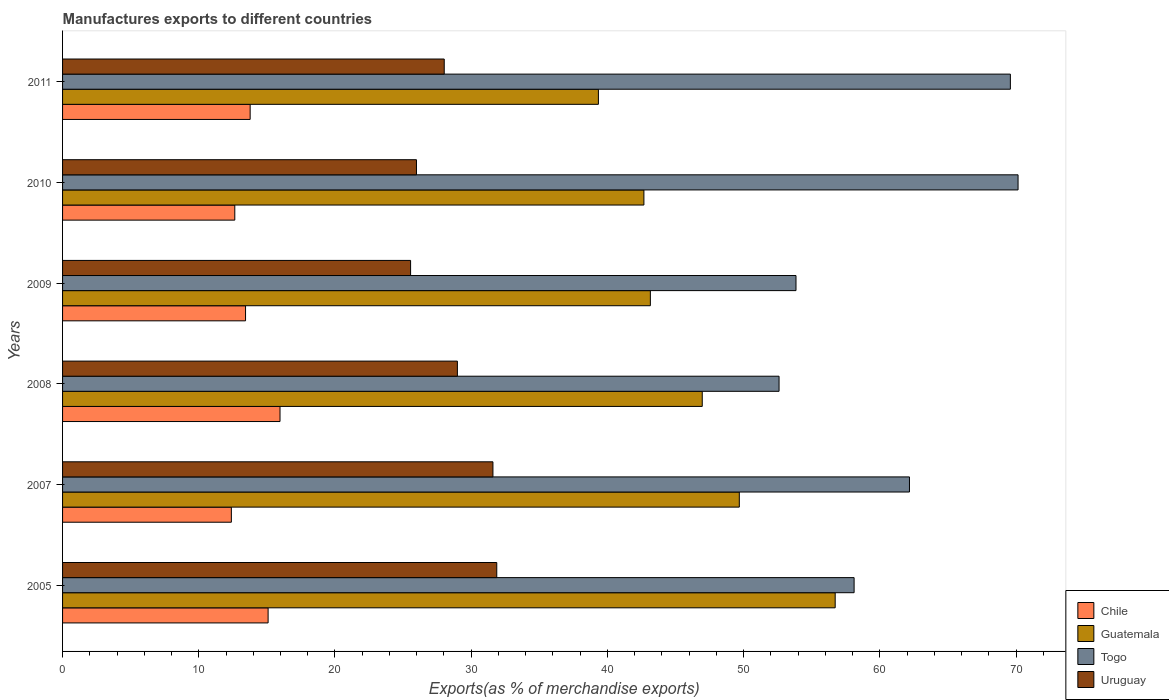How many groups of bars are there?
Ensure brevity in your answer.  6. How many bars are there on the 1st tick from the bottom?
Give a very brief answer. 4. In how many cases, is the number of bars for a given year not equal to the number of legend labels?
Offer a terse response. 0. What is the percentage of exports to different countries in Togo in 2007?
Give a very brief answer. 62.18. Across all years, what is the maximum percentage of exports to different countries in Togo?
Provide a succinct answer. 70.15. Across all years, what is the minimum percentage of exports to different countries in Chile?
Offer a very short reply. 12.39. What is the total percentage of exports to different countries in Uruguay in the graph?
Offer a very short reply. 172.01. What is the difference between the percentage of exports to different countries in Chile in 2005 and that in 2010?
Your response must be concise. 2.45. What is the difference between the percentage of exports to different countries in Uruguay in 2005 and the percentage of exports to different countries in Chile in 2007?
Make the answer very short. 19.49. What is the average percentage of exports to different countries in Chile per year?
Make the answer very short. 13.88. In the year 2008, what is the difference between the percentage of exports to different countries in Togo and percentage of exports to different countries in Chile?
Offer a very short reply. 36.64. What is the ratio of the percentage of exports to different countries in Togo in 2007 to that in 2011?
Your answer should be very brief. 0.89. Is the percentage of exports to different countries in Togo in 2007 less than that in 2011?
Your response must be concise. Yes. What is the difference between the highest and the second highest percentage of exports to different countries in Uruguay?
Your answer should be compact. 0.28. What is the difference between the highest and the lowest percentage of exports to different countries in Uruguay?
Offer a very short reply. 6.33. Is the sum of the percentage of exports to different countries in Uruguay in 2005 and 2007 greater than the maximum percentage of exports to different countries in Chile across all years?
Your answer should be compact. Yes. Is it the case that in every year, the sum of the percentage of exports to different countries in Togo and percentage of exports to different countries in Uruguay is greater than the sum of percentage of exports to different countries in Chile and percentage of exports to different countries in Guatemala?
Offer a very short reply. Yes. What does the 1st bar from the top in 2010 represents?
Provide a short and direct response. Uruguay. What does the 2nd bar from the bottom in 2008 represents?
Provide a succinct answer. Guatemala. Is it the case that in every year, the sum of the percentage of exports to different countries in Togo and percentage of exports to different countries in Guatemala is greater than the percentage of exports to different countries in Chile?
Offer a terse response. Yes. How many bars are there?
Your response must be concise. 24. How many years are there in the graph?
Ensure brevity in your answer.  6. Does the graph contain grids?
Your response must be concise. No. Where does the legend appear in the graph?
Provide a short and direct response. Bottom right. What is the title of the graph?
Your answer should be very brief. Manufactures exports to different countries. What is the label or title of the X-axis?
Provide a succinct answer. Exports(as % of merchandise exports). What is the Exports(as % of merchandise exports) in Chile in 2005?
Offer a terse response. 15.09. What is the Exports(as % of merchandise exports) in Guatemala in 2005?
Provide a succinct answer. 56.72. What is the Exports(as % of merchandise exports) of Togo in 2005?
Offer a terse response. 58.11. What is the Exports(as % of merchandise exports) in Uruguay in 2005?
Give a very brief answer. 31.88. What is the Exports(as % of merchandise exports) in Chile in 2007?
Ensure brevity in your answer.  12.39. What is the Exports(as % of merchandise exports) in Guatemala in 2007?
Your answer should be very brief. 49.68. What is the Exports(as % of merchandise exports) in Togo in 2007?
Provide a succinct answer. 62.18. What is the Exports(as % of merchandise exports) in Uruguay in 2007?
Give a very brief answer. 31.6. What is the Exports(as % of merchandise exports) of Chile in 2008?
Your response must be concise. 15.96. What is the Exports(as % of merchandise exports) of Guatemala in 2008?
Your answer should be compact. 46.96. What is the Exports(as % of merchandise exports) in Togo in 2008?
Offer a very short reply. 52.6. What is the Exports(as % of merchandise exports) in Uruguay in 2008?
Ensure brevity in your answer.  28.99. What is the Exports(as % of merchandise exports) in Chile in 2009?
Your answer should be compact. 13.43. What is the Exports(as % of merchandise exports) in Guatemala in 2009?
Your answer should be compact. 43.15. What is the Exports(as % of merchandise exports) of Togo in 2009?
Make the answer very short. 53.85. What is the Exports(as % of merchandise exports) in Uruguay in 2009?
Offer a terse response. 25.55. What is the Exports(as % of merchandise exports) of Chile in 2010?
Offer a very short reply. 12.64. What is the Exports(as % of merchandise exports) of Guatemala in 2010?
Your answer should be compact. 42.68. What is the Exports(as % of merchandise exports) of Togo in 2010?
Offer a very short reply. 70.15. What is the Exports(as % of merchandise exports) of Uruguay in 2010?
Provide a succinct answer. 25.98. What is the Exports(as % of merchandise exports) of Chile in 2011?
Make the answer very short. 13.77. What is the Exports(as % of merchandise exports) of Guatemala in 2011?
Your response must be concise. 39.34. What is the Exports(as % of merchandise exports) of Togo in 2011?
Offer a very short reply. 69.58. What is the Exports(as % of merchandise exports) in Uruguay in 2011?
Your response must be concise. 28.02. Across all years, what is the maximum Exports(as % of merchandise exports) in Chile?
Your answer should be very brief. 15.96. Across all years, what is the maximum Exports(as % of merchandise exports) in Guatemala?
Provide a short and direct response. 56.72. Across all years, what is the maximum Exports(as % of merchandise exports) in Togo?
Your response must be concise. 70.15. Across all years, what is the maximum Exports(as % of merchandise exports) in Uruguay?
Ensure brevity in your answer.  31.88. Across all years, what is the minimum Exports(as % of merchandise exports) in Chile?
Your answer should be compact. 12.39. Across all years, what is the minimum Exports(as % of merchandise exports) of Guatemala?
Ensure brevity in your answer.  39.34. Across all years, what is the minimum Exports(as % of merchandise exports) of Togo?
Keep it short and to the point. 52.6. Across all years, what is the minimum Exports(as % of merchandise exports) in Uruguay?
Your answer should be compact. 25.55. What is the total Exports(as % of merchandise exports) of Chile in the graph?
Provide a short and direct response. 83.3. What is the total Exports(as % of merchandise exports) of Guatemala in the graph?
Provide a short and direct response. 278.54. What is the total Exports(as % of merchandise exports) in Togo in the graph?
Your response must be concise. 366.47. What is the total Exports(as % of merchandise exports) of Uruguay in the graph?
Give a very brief answer. 172.01. What is the difference between the Exports(as % of merchandise exports) of Chile in 2005 and that in 2007?
Keep it short and to the point. 2.7. What is the difference between the Exports(as % of merchandise exports) in Guatemala in 2005 and that in 2007?
Provide a succinct answer. 7.04. What is the difference between the Exports(as % of merchandise exports) in Togo in 2005 and that in 2007?
Your response must be concise. -4.06. What is the difference between the Exports(as % of merchandise exports) of Uruguay in 2005 and that in 2007?
Make the answer very short. 0.28. What is the difference between the Exports(as % of merchandise exports) in Chile in 2005 and that in 2008?
Your answer should be compact. -0.87. What is the difference between the Exports(as % of merchandise exports) of Guatemala in 2005 and that in 2008?
Your answer should be compact. 9.76. What is the difference between the Exports(as % of merchandise exports) in Togo in 2005 and that in 2008?
Your answer should be compact. 5.51. What is the difference between the Exports(as % of merchandise exports) in Uruguay in 2005 and that in 2008?
Provide a short and direct response. 2.89. What is the difference between the Exports(as % of merchandise exports) in Chile in 2005 and that in 2009?
Your answer should be very brief. 1.66. What is the difference between the Exports(as % of merchandise exports) in Guatemala in 2005 and that in 2009?
Your answer should be compact. 13.57. What is the difference between the Exports(as % of merchandise exports) in Togo in 2005 and that in 2009?
Your answer should be very brief. 4.27. What is the difference between the Exports(as % of merchandise exports) in Uruguay in 2005 and that in 2009?
Offer a very short reply. 6.33. What is the difference between the Exports(as % of merchandise exports) of Chile in 2005 and that in 2010?
Your answer should be very brief. 2.45. What is the difference between the Exports(as % of merchandise exports) of Guatemala in 2005 and that in 2010?
Keep it short and to the point. 14.04. What is the difference between the Exports(as % of merchandise exports) of Togo in 2005 and that in 2010?
Make the answer very short. -12.04. What is the difference between the Exports(as % of merchandise exports) of Uruguay in 2005 and that in 2010?
Your response must be concise. 5.9. What is the difference between the Exports(as % of merchandise exports) of Chile in 2005 and that in 2011?
Make the answer very short. 1.32. What is the difference between the Exports(as % of merchandise exports) in Guatemala in 2005 and that in 2011?
Offer a terse response. 17.38. What is the difference between the Exports(as % of merchandise exports) of Togo in 2005 and that in 2011?
Provide a succinct answer. -11.47. What is the difference between the Exports(as % of merchandise exports) of Uruguay in 2005 and that in 2011?
Provide a short and direct response. 3.86. What is the difference between the Exports(as % of merchandise exports) of Chile in 2007 and that in 2008?
Offer a very short reply. -3.57. What is the difference between the Exports(as % of merchandise exports) in Guatemala in 2007 and that in 2008?
Your answer should be very brief. 2.72. What is the difference between the Exports(as % of merchandise exports) in Togo in 2007 and that in 2008?
Provide a succinct answer. 9.57. What is the difference between the Exports(as % of merchandise exports) in Uruguay in 2007 and that in 2008?
Provide a succinct answer. 2.61. What is the difference between the Exports(as % of merchandise exports) of Chile in 2007 and that in 2009?
Offer a very short reply. -1.04. What is the difference between the Exports(as % of merchandise exports) of Guatemala in 2007 and that in 2009?
Make the answer very short. 6.53. What is the difference between the Exports(as % of merchandise exports) of Togo in 2007 and that in 2009?
Provide a succinct answer. 8.33. What is the difference between the Exports(as % of merchandise exports) of Uruguay in 2007 and that in 2009?
Make the answer very short. 6.04. What is the difference between the Exports(as % of merchandise exports) of Chile in 2007 and that in 2010?
Ensure brevity in your answer.  -0.25. What is the difference between the Exports(as % of merchandise exports) in Guatemala in 2007 and that in 2010?
Provide a succinct answer. 7. What is the difference between the Exports(as % of merchandise exports) of Togo in 2007 and that in 2010?
Offer a terse response. -7.97. What is the difference between the Exports(as % of merchandise exports) in Uruguay in 2007 and that in 2010?
Your answer should be very brief. 5.61. What is the difference between the Exports(as % of merchandise exports) in Chile in 2007 and that in 2011?
Keep it short and to the point. -1.38. What is the difference between the Exports(as % of merchandise exports) of Guatemala in 2007 and that in 2011?
Ensure brevity in your answer.  10.34. What is the difference between the Exports(as % of merchandise exports) in Togo in 2007 and that in 2011?
Give a very brief answer. -7.41. What is the difference between the Exports(as % of merchandise exports) of Uruguay in 2007 and that in 2011?
Offer a very short reply. 3.58. What is the difference between the Exports(as % of merchandise exports) of Chile in 2008 and that in 2009?
Offer a very short reply. 2.53. What is the difference between the Exports(as % of merchandise exports) in Guatemala in 2008 and that in 2009?
Your answer should be very brief. 3.81. What is the difference between the Exports(as % of merchandise exports) of Togo in 2008 and that in 2009?
Your response must be concise. -1.24. What is the difference between the Exports(as % of merchandise exports) in Uruguay in 2008 and that in 2009?
Offer a terse response. 3.44. What is the difference between the Exports(as % of merchandise exports) of Chile in 2008 and that in 2010?
Keep it short and to the point. 3.32. What is the difference between the Exports(as % of merchandise exports) of Guatemala in 2008 and that in 2010?
Your response must be concise. 4.28. What is the difference between the Exports(as % of merchandise exports) in Togo in 2008 and that in 2010?
Your answer should be very brief. -17.55. What is the difference between the Exports(as % of merchandise exports) in Uruguay in 2008 and that in 2010?
Offer a very short reply. 3. What is the difference between the Exports(as % of merchandise exports) in Chile in 2008 and that in 2011?
Give a very brief answer. 2.19. What is the difference between the Exports(as % of merchandise exports) in Guatemala in 2008 and that in 2011?
Provide a short and direct response. 7.62. What is the difference between the Exports(as % of merchandise exports) of Togo in 2008 and that in 2011?
Your answer should be very brief. -16.98. What is the difference between the Exports(as % of merchandise exports) in Uruguay in 2008 and that in 2011?
Provide a succinct answer. 0.97. What is the difference between the Exports(as % of merchandise exports) of Chile in 2009 and that in 2010?
Give a very brief answer. 0.79. What is the difference between the Exports(as % of merchandise exports) in Guatemala in 2009 and that in 2010?
Your answer should be very brief. 0.47. What is the difference between the Exports(as % of merchandise exports) in Togo in 2009 and that in 2010?
Offer a very short reply. -16.3. What is the difference between the Exports(as % of merchandise exports) of Uruguay in 2009 and that in 2010?
Your answer should be compact. -0.43. What is the difference between the Exports(as % of merchandise exports) in Chile in 2009 and that in 2011?
Your response must be concise. -0.34. What is the difference between the Exports(as % of merchandise exports) of Guatemala in 2009 and that in 2011?
Offer a very short reply. 3.81. What is the difference between the Exports(as % of merchandise exports) of Togo in 2009 and that in 2011?
Your response must be concise. -15.74. What is the difference between the Exports(as % of merchandise exports) of Uruguay in 2009 and that in 2011?
Provide a succinct answer. -2.47. What is the difference between the Exports(as % of merchandise exports) of Chile in 2010 and that in 2011?
Provide a succinct answer. -1.13. What is the difference between the Exports(as % of merchandise exports) in Guatemala in 2010 and that in 2011?
Make the answer very short. 3.34. What is the difference between the Exports(as % of merchandise exports) of Togo in 2010 and that in 2011?
Give a very brief answer. 0.56. What is the difference between the Exports(as % of merchandise exports) in Uruguay in 2010 and that in 2011?
Your response must be concise. -2.04. What is the difference between the Exports(as % of merchandise exports) in Chile in 2005 and the Exports(as % of merchandise exports) in Guatemala in 2007?
Offer a very short reply. -34.59. What is the difference between the Exports(as % of merchandise exports) in Chile in 2005 and the Exports(as % of merchandise exports) in Togo in 2007?
Your answer should be very brief. -47.09. What is the difference between the Exports(as % of merchandise exports) of Chile in 2005 and the Exports(as % of merchandise exports) of Uruguay in 2007?
Your response must be concise. -16.51. What is the difference between the Exports(as % of merchandise exports) in Guatemala in 2005 and the Exports(as % of merchandise exports) in Togo in 2007?
Keep it short and to the point. -5.45. What is the difference between the Exports(as % of merchandise exports) in Guatemala in 2005 and the Exports(as % of merchandise exports) in Uruguay in 2007?
Provide a succinct answer. 25.13. What is the difference between the Exports(as % of merchandise exports) of Togo in 2005 and the Exports(as % of merchandise exports) of Uruguay in 2007?
Keep it short and to the point. 26.52. What is the difference between the Exports(as % of merchandise exports) of Chile in 2005 and the Exports(as % of merchandise exports) of Guatemala in 2008?
Your response must be concise. -31.87. What is the difference between the Exports(as % of merchandise exports) of Chile in 2005 and the Exports(as % of merchandise exports) of Togo in 2008?
Your answer should be very brief. -37.51. What is the difference between the Exports(as % of merchandise exports) of Chile in 2005 and the Exports(as % of merchandise exports) of Uruguay in 2008?
Your response must be concise. -13.9. What is the difference between the Exports(as % of merchandise exports) in Guatemala in 2005 and the Exports(as % of merchandise exports) in Togo in 2008?
Offer a very short reply. 4.12. What is the difference between the Exports(as % of merchandise exports) of Guatemala in 2005 and the Exports(as % of merchandise exports) of Uruguay in 2008?
Your answer should be compact. 27.74. What is the difference between the Exports(as % of merchandise exports) of Togo in 2005 and the Exports(as % of merchandise exports) of Uruguay in 2008?
Your response must be concise. 29.12. What is the difference between the Exports(as % of merchandise exports) of Chile in 2005 and the Exports(as % of merchandise exports) of Guatemala in 2009?
Give a very brief answer. -28.06. What is the difference between the Exports(as % of merchandise exports) in Chile in 2005 and the Exports(as % of merchandise exports) in Togo in 2009?
Your answer should be compact. -38.76. What is the difference between the Exports(as % of merchandise exports) of Chile in 2005 and the Exports(as % of merchandise exports) of Uruguay in 2009?
Provide a short and direct response. -10.46. What is the difference between the Exports(as % of merchandise exports) of Guatemala in 2005 and the Exports(as % of merchandise exports) of Togo in 2009?
Your response must be concise. 2.88. What is the difference between the Exports(as % of merchandise exports) of Guatemala in 2005 and the Exports(as % of merchandise exports) of Uruguay in 2009?
Your response must be concise. 31.17. What is the difference between the Exports(as % of merchandise exports) in Togo in 2005 and the Exports(as % of merchandise exports) in Uruguay in 2009?
Ensure brevity in your answer.  32.56. What is the difference between the Exports(as % of merchandise exports) in Chile in 2005 and the Exports(as % of merchandise exports) in Guatemala in 2010?
Offer a very short reply. -27.59. What is the difference between the Exports(as % of merchandise exports) of Chile in 2005 and the Exports(as % of merchandise exports) of Togo in 2010?
Keep it short and to the point. -55.06. What is the difference between the Exports(as % of merchandise exports) of Chile in 2005 and the Exports(as % of merchandise exports) of Uruguay in 2010?
Your response must be concise. -10.89. What is the difference between the Exports(as % of merchandise exports) of Guatemala in 2005 and the Exports(as % of merchandise exports) of Togo in 2010?
Offer a terse response. -13.43. What is the difference between the Exports(as % of merchandise exports) of Guatemala in 2005 and the Exports(as % of merchandise exports) of Uruguay in 2010?
Your response must be concise. 30.74. What is the difference between the Exports(as % of merchandise exports) of Togo in 2005 and the Exports(as % of merchandise exports) of Uruguay in 2010?
Offer a very short reply. 32.13. What is the difference between the Exports(as % of merchandise exports) of Chile in 2005 and the Exports(as % of merchandise exports) of Guatemala in 2011?
Your answer should be very brief. -24.25. What is the difference between the Exports(as % of merchandise exports) of Chile in 2005 and the Exports(as % of merchandise exports) of Togo in 2011?
Ensure brevity in your answer.  -54.49. What is the difference between the Exports(as % of merchandise exports) of Chile in 2005 and the Exports(as % of merchandise exports) of Uruguay in 2011?
Give a very brief answer. -12.93. What is the difference between the Exports(as % of merchandise exports) of Guatemala in 2005 and the Exports(as % of merchandise exports) of Togo in 2011?
Your response must be concise. -12.86. What is the difference between the Exports(as % of merchandise exports) in Guatemala in 2005 and the Exports(as % of merchandise exports) in Uruguay in 2011?
Your answer should be compact. 28.7. What is the difference between the Exports(as % of merchandise exports) in Togo in 2005 and the Exports(as % of merchandise exports) in Uruguay in 2011?
Provide a succinct answer. 30.09. What is the difference between the Exports(as % of merchandise exports) in Chile in 2007 and the Exports(as % of merchandise exports) in Guatemala in 2008?
Your response must be concise. -34.57. What is the difference between the Exports(as % of merchandise exports) of Chile in 2007 and the Exports(as % of merchandise exports) of Togo in 2008?
Offer a very short reply. -40.21. What is the difference between the Exports(as % of merchandise exports) of Chile in 2007 and the Exports(as % of merchandise exports) of Uruguay in 2008?
Offer a very short reply. -16.59. What is the difference between the Exports(as % of merchandise exports) of Guatemala in 2007 and the Exports(as % of merchandise exports) of Togo in 2008?
Give a very brief answer. -2.92. What is the difference between the Exports(as % of merchandise exports) of Guatemala in 2007 and the Exports(as % of merchandise exports) of Uruguay in 2008?
Offer a very short reply. 20.7. What is the difference between the Exports(as % of merchandise exports) of Togo in 2007 and the Exports(as % of merchandise exports) of Uruguay in 2008?
Give a very brief answer. 33.19. What is the difference between the Exports(as % of merchandise exports) in Chile in 2007 and the Exports(as % of merchandise exports) in Guatemala in 2009?
Provide a short and direct response. -30.76. What is the difference between the Exports(as % of merchandise exports) in Chile in 2007 and the Exports(as % of merchandise exports) in Togo in 2009?
Your answer should be very brief. -41.45. What is the difference between the Exports(as % of merchandise exports) in Chile in 2007 and the Exports(as % of merchandise exports) in Uruguay in 2009?
Provide a succinct answer. -13.16. What is the difference between the Exports(as % of merchandise exports) of Guatemala in 2007 and the Exports(as % of merchandise exports) of Togo in 2009?
Offer a terse response. -4.16. What is the difference between the Exports(as % of merchandise exports) of Guatemala in 2007 and the Exports(as % of merchandise exports) of Uruguay in 2009?
Your answer should be very brief. 24.13. What is the difference between the Exports(as % of merchandise exports) of Togo in 2007 and the Exports(as % of merchandise exports) of Uruguay in 2009?
Provide a succinct answer. 36.63. What is the difference between the Exports(as % of merchandise exports) of Chile in 2007 and the Exports(as % of merchandise exports) of Guatemala in 2010?
Your answer should be compact. -30.29. What is the difference between the Exports(as % of merchandise exports) in Chile in 2007 and the Exports(as % of merchandise exports) in Togo in 2010?
Your answer should be very brief. -57.76. What is the difference between the Exports(as % of merchandise exports) in Chile in 2007 and the Exports(as % of merchandise exports) in Uruguay in 2010?
Give a very brief answer. -13.59. What is the difference between the Exports(as % of merchandise exports) in Guatemala in 2007 and the Exports(as % of merchandise exports) in Togo in 2010?
Keep it short and to the point. -20.47. What is the difference between the Exports(as % of merchandise exports) of Guatemala in 2007 and the Exports(as % of merchandise exports) of Uruguay in 2010?
Ensure brevity in your answer.  23.7. What is the difference between the Exports(as % of merchandise exports) in Togo in 2007 and the Exports(as % of merchandise exports) in Uruguay in 2010?
Offer a terse response. 36.19. What is the difference between the Exports(as % of merchandise exports) in Chile in 2007 and the Exports(as % of merchandise exports) in Guatemala in 2011?
Offer a terse response. -26.95. What is the difference between the Exports(as % of merchandise exports) of Chile in 2007 and the Exports(as % of merchandise exports) of Togo in 2011?
Give a very brief answer. -57.19. What is the difference between the Exports(as % of merchandise exports) of Chile in 2007 and the Exports(as % of merchandise exports) of Uruguay in 2011?
Offer a terse response. -15.63. What is the difference between the Exports(as % of merchandise exports) of Guatemala in 2007 and the Exports(as % of merchandise exports) of Togo in 2011?
Your answer should be very brief. -19.9. What is the difference between the Exports(as % of merchandise exports) in Guatemala in 2007 and the Exports(as % of merchandise exports) in Uruguay in 2011?
Offer a terse response. 21.66. What is the difference between the Exports(as % of merchandise exports) in Togo in 2007 and the Exports(as % of merchandise exports) in Uruguay in 2011?
Keep it short and to the point. 34.16. What is the difference between the Exports(as % of merchandise exports) in Chile in 2008 and the Exports(as % of merchandise exports) in Guatemala in 2009?
Offer a very short reply. -27.19. What is the difference between the Exports(as % of merchandise exports) in Chile in 2008 and the Exports(as % of merchandise exports) in Togo in 2009?
Your response must be concise. -37.88. What is the difference between the Exports(as % of merchandise exports) of Chile in 2008 and the Exports(as % of merchandise exports) of Uruguay in 2009?
Offer a very short reply. -9.59. What is the difference between the Exports(as % of merchandise exports) of Guatemala in 2008 and the Exports(as % of merchandise exports) of Togo in 2009?
Ensure brevity in your answer.  -6.88. What is the difference between the Exports(as % of merchandise exports) in Guatemala in 2008 and the Exports(as % of merchandise exports) in Uruguay in 2009?
Offer a terse response. 21.41. What is the difference between the Exports(as % of merchandise exports) of Togo in 2008 and the Exports(as % of merchandise exports) of Uruguay in 2009?
Offer a terse response. 27.05. What is the difference between the Exports(as % of merchandise exports) of Chile in 2008 and the Exports(as % of merchandise exports) of Guatemala in 2010?
Ensure brevity in your answer.  -26.72. What is the difference between the Exports(as % of merchandise exports) in Chile in 2008 and the Exports(as % of merchandise exports) in Togo in 2010?
Your answer should be compact. -54.18. What is the difference between the Exports(as % of merchandise exports) of Chile in 2008 and the Exports(as % of merchandise exports) of Uruguay in 2010?
Your answer should be very brief. -10.02. What is the difference between the Exports(as % of merchandise exports) of Guatemala in 2008 and the Exports(as % of merchandise exports) of Togo in 2010?
Your response must be concise. -23.19. What is the difference between the Exports(as % of merchandise exports) of Guatemala in 2008 and the Exports(as % of merchandise exports) of Uruguay in 2010?
Keep it short and to the point. 20.98. What is the difference between the Exports(as % of merchandise exports) in Togo in 2008 and the Exports(as % of merchandise exports) in Uruguay in 2010?
Provide a succinct answer. 26.62. What is the difference between the Exports(as % of merchandise exports) of Chile in 2008 and the Exports(as % of merchandise exports) of Guatemala in 2011?
Keep it short and to the point. -23.37. What is the difference between the Exports(as % of merchandise exports) in Chile in 2008 and the Exports(as % of merchandise exports) in Togo in 2011?
Give a very brief answer. -53.62. What is the difference between the Exports(as % of merchandise exports) of Chile in 2008 and the Exports(as % of merchandise exports) of Uruguay in 2011?
Your response must be concise. -12.06. What is the difference between the Exports(as % of merchandise exports) in Guatemala in 2008 and the Exports(as % of merchandise exports) in Togo in 2011?
Keep it short and to the point. -22.62. What is the difference between the Exports(as % of merchandise exports) of Guatemala in 2008 and the Exports(as % of merchandise exports) of Uruguay in 2011?
Offer a terse response. 18.94. What is the difference between the Exports(as % of merchandise exports) in Togo in 2008 and the Exports(as % of merchandise exports) in Uruguay in 2011?
Keep it short and to the point. 24.58. What is the difference between the Exports(as % of merchandise exports) of Chile in 2009 and the Exports(as % of merchandise exports) of Guatemala in 2010?
Provide a succinct answer. -29.25. What is the difference between the Exports(as % of merchandise exports) in Chile in 2009 and the Exports(as % of merchandise exports) in Togo in 2010?
Provide a succinct answer. -56.72. What is the difference between the Exports(as % of merchandise exports) in Chile in 2009 and the Exports(as % of merchandise exports) in Uruguay in 2010?
Offer a terse response. -12.55. What is the difference between the Exports(as % of merchandise exports) in Guatemala in 2009 and the Exports(as % of merchandise exports) in Togo in 2010?
Offer a terse response. -27. What is the difference between the Exports(as % of merchandise exports) in Guatemala in 2009 and the Exports(as % of merchandise exports) in Uruguay in 2010?
Provide a succinct answer. 17.17. What is the difference between the Exports(as % of merchandise exports) in Togo in 2009 and the Exports(as % of merchandise exports) in Uruguay in 2010?
Provide a short and direct response. 27.86. What is the difference between the Exports(as % of merchandise exports) of Chile in 2009 and the Exports(as % of merchandise exports) of Guatemala in 2011?
Provide a short and direct response. -25.91. What is the difference between the Exports(as % of merchandise exports) in Chile in 2009 and the Exports(as % of merchandise exports) in Togo in 2011?
Your answer should be compact. -56.15. What is the difference between the Exports(as % of merchandise exports) of Chile in 2009 and the Exports(as % of merchandise exports) of Uruguay in 2011?
Your answer should be very brief. -14.59. What is the difference between the Exports(as % of merchandise exports) in Guatemala in 2009 and the Exports(as % of merchandise exports) in Togo in 2011?
Make the answer very short. -26.43. What is the difference between the Exports(as % of merchandise exports) in Guatemala in 2009 and the Exports(as % of merchandise exports) in Uruguay in 2011?
Your response must be concise. 15.13. What is the difference between the Exports(as % of merchandise exports) of Togo in 2009 and the Exports(as % of merchandise exports) of Uruguay in 2011?
Offer a very short reply. 25.83. What is the difference between the Exports(as % of merchandise exports) of Chile in 2010 and the Exports(as % of merchandise exports) of Guatemala in 2011?
Your response must be concise. -26.69. What is the difference between the Exports(as % of merchandise exports) of Chile in 2010 and the Exports(as % of merchandise exports) of Togo in 2011?
Your response must be concise. -56.94. What is the difference between the Exports(as % of merchandise exports) of Chile in 2010 and the Exports(as % of merchandise exports) of Uruguay in 2011?
Offer a very short reply. -15.38. What is the difference between the Exports(as % of merchandise exports) of Guatemala in 2010 and the Exports(as % of merchandise exports) of Togo in 2011?
Offer a terse response. -26.9. What is the difference between the Exports(as % of merchandise exports) in Guatemala in 2010 and the Exports(as % of merchandise exports) in Uruguay in 2011?
Provide a short and direct response. 14.66. What is the difference between the Exports(as % of merchandise exports) in Togo in 2010 and the Exports(as % of merchandise exports) in Uruguay in 2011?
Keep it short and to the point. 42.13. What is the average Exports(as % of merchandise exports) in Chile per year?
Offer a terse response. 13.88. What is the average Exports(as % of merchandise exports) of Guatemala per year?
Ensure brevity in your answer.  46.42. What is the average Exports(as % of merchandise exports) of Togo per year?
Give a very brief answer. 61.08. What is the average Exports(as % of merchandise exports) of Uruguay per year?
Offer a terse response. 28.67. In the year 2005, what is the difference between the Exports(as % of merchandise exports) in Chile and Exports(as % of merchandise exports) in Guatemala?
Your response must be concise. -41.63. In the year 2005, what is the difference between the Exports(as % of merchandise exports) in Chile and Exports(as % of merchandise exports) in Togo?
Offer a very short reply. -43.02. In the year 2005, what is the difference between the Exports(as % of merchandise exports) in Chile and Exports(as % of merchandise exports) in Uruguay?
Your answer should be compact. -16.79. In the year 2005, what is the difference between the Exports(as % of merchandise exports) of Guatemala and Exports(as % of merchandise exports) of Togo?
Offer a very short reply. -1.39. In the year 2005, what is the difference between the Exports(as % of merchandise exports) of Guatemala and Exports(as % of merchandise exports) of Uruguay?
Your response must be concise. 24.85. In the year 2005, what is the difference between the Exports(as % of merchandise exports) of Togo and Exports(as % of merchandise exports) of Uruguay?
Offer a very short reply. 26.23. In the year 2007, what is the difference between the Exports(as % of merchandise exports) of Chile and Exports(as % of merchandise exports) of Guatemala?
Your response must be concise. -37.29. In the year 2007, what is the difference between the Exports(as % of merchandise exports) of Chile and Exports(as % of merchandise exports) of Togo?
Offer a very short reply. -49.78. In the year 2007, what is the difference between the Exports(as % of merchandise exports) in Chile and Exports(as % of merchandise exports) in Uruguay?
Ensure brevity in your answer.  -19.2. In the year 2007, what is the difference between the Exports(as % of merchandise exports) of Guatemala and Exports(as % of merchandise exports) of Togo?
Provide a short and direct response. -12.49. In the year 2007, what is the difference between the Exports(as % of merchandise exports) in Guatemala and Exports(as % of merchandise exports) in Uruguay?
Give a very brief answer. 18.09. In the year 2007, what is the difference between the Exports(as % of merchandise exports) of Togo and Exports(as % of merchandise exports) of Uruguay?
Offer a very short reply. 30.58. In the year 2008, what is the difference between the Exports(as % of merchandise exports) of Chile and Exports(as % of merchandise exports) of Guatemala?
Keep it short and to the point. -31. In the year 2008, what is the difference between the Exports(as % of merchandise exports) of Chile and Exports(as % of merchandise exports) of Togo?
Your answer should be very brief. -36.64. In the year 2008, what is the difference between the Exports(as % of merchandise exports) in Chile and Exports(as % of merchandise exports) in Uruguay?
Offer a very short reply. -13.02. In the year 2008, what is the difference between the Exports(as % of merchandise exports) of Guatemala and Exports(as % of merchandise exports) of Togo?
Ensure brevity in your answer.  -5.64. In the year 2008, what is the difference between the Exports(as % of merchandise exports) of Guatemala and Exports(as % of merchandise exports) of Uruguay?
Provide a short and direct response. 17.98. In the year 2008, what is the difference between the Exports(as % of merchandise exports) of Togo and Exports(as % of merchandise exports) of Uruguay?
Give a very brief answer. 23.62. In the year 2009, what is the difference between the Exports(as % of merchandise exports) of Chile and Exports(as % of merchandise exports) of Guatemala?
Offer a terse response. -29.72. In the year 2009, what is the difference between the Exports(as % of merchandise exports) of Chile and Exports(as % of merchandise exports) of Togo?
Make the answer very short. -40.41. In the year 2009, what is the difference between the Exports(as % of merchandise exports) of Chile and Exports(as % of merchandise exports) of Uruguay?
Offer a very short reply. -12.12. In the year 2009, what is the difference between the Exports(as % of merchandise exports) of Guatemala and Exports(as % of merchandise exports) of Togo?
Give a very brief answer. -10.69. In the year 2009, what is the difference between the Exports(as % of merchandise exports) in Guatemala and Exports(as % of merchandise exports) in Uruguay?
Ensure brevity in your answer.  17.6. In the year 2009, what is the difference between the Exports(as % of merchandise exports) in Togo and Exports(as % of merchandise exports) in Uruguay?
Your response must be concise. 28.29. In the year 2010, what is the difference between the Exports(as % of merchandise exports) in Chile and Exports(as % of merchandise exports) in Guatemala?
Your response must be concise. -30.04. In the year 2010, what is the difference between the Exports(as % of merchandise exports) in Chile and Exports(as % of merchandise exports) in Togo?
Make the answer very short. -57.5. In the year 2010, what is the difference between the Exports(as % of merchandise exports) in Chile and Exports(as % of merchandise exports) in Uruguay?
Offer a very short reply. -13.34. In the year 2010, what is the difference between the Exports(as % of merchandise exports) in Guatemala and Exports(as % of merchandise exports) in Togo?
Make the answer very short. -27.47. In the year 2010, what is the difference between the Exports(as % of merchandise exports) of Guatemala and Exports(as % of merchandise exports) of Uruguay?
Your answer should be very brief. 16.7. In the year 2010, what is the difference between the Exports(as % of merchandise exports) in Togo and Exports(as % of merchandise exports) in Uruguay?
Give a very brief answer. 44.17. In the year 2011, what is the difference between the Exports(as % of merchandise exports) in Chile and Exports(as % of merchandise exports) in Guatemala?
Ensure brevity in your answer.  -25.57. In the year 2011, what is the difference between the Exports(as % of merchandise exports) in Chile and Exports(as % of merchandise exports) in Togo?
Offer a terse response. -55.81. In the year 2011, what is the difference between the Exports(as % of merchandise exports) in Chile and Exports(as % of merchandise exports) in Uruguay?
Provide a short and direct response. -14.25. In the year 2011, what is the difference between the Exports(as % of merchandise exports) in Guatemala and Exports(as % of merchandise exports) in Togo?
Offer a terse response. -30.24. In the year 2011, what is the difference between the Exports(as % of merchandise exports) in Guatemala and Exports(as % of merchandise exports) in Uruguay?
Your answer should be very brief. 11.32. In the year 2011, what is the difference between the Exports(as % of merchandise exports) of Togo and Exports(as % of merchandise exports) of Uruguay?
Your response must be concise. 41.56. What is the ratio of the Exports(as % of merchandise exports) of Chile in 2005 to that in 2007?
Offer a very short reply. 1.22. What is the ratio of the Exports(as % of merchandise exports) in Guatemala in 2005 to that in 2007?
Ensure brevity in your answer.  1.14. What is the ratio of the Exports(as % of merchandise exports) in Togo in 2005 to that in 2007?
Keep it short and to the point. 0.93. What is the ratio of the Exports(as % of merchandise exports) of Uruguay in 2005 to that in 2007?
Provide a short and direct response. 1.01. What is the ratio of the Exports(as % of merchandise exports) in Chile in 2005 to that in 2008?
Ensure brevity in your answer.  0.95. What is the ratio of the Exports(as % of merchandise exports) in Guatemala in 2005 to that in 2008?
Your answer should be very brief. 1.21. What is the ratio of the Exports(as % of merchandise exports) of Togo in 2005 to that in 2008?
Ensure brevity in your answer.  1.1. What is the ratio of the Exports(as % of merchandise exports) in Uruguay in 2005 to that in 2008?
Your answer should be very brief. 1.1. What is the ratio of the Exports(as % of merchandise exports) in Chile in 2005 to that in 2009?
Give a very brief answer. 1.12. What is the ratio of the Exports(as % of merchandise exports) of Guatemala in 2005 to that in 2009?
Ensure brevity in your answer.  1.31. What is the ratio of the Exports(as % of merchandise exports) in Togo in 2005 to that in 2009?
Provide a succinct answer. 1.08. What is the ratio of the Exports(as % of merchandise exports) of Uruguay in 2005 to that in 2009?
Your response must be concise. 1.25. What is the ratio of the Exports(as % of merchandise exports) in Chile in 2005 to that in 2010?
Make the answer very short. 1.19. What is the ratio of the Exports(as % of merchandise exports) of Guatemala in 2005 to that in 2010?
Keep it short and to the point. 1.33. What is the ratio of the Exports(as % of merchandise exports) of Togo in 2005 to that in 2010?
Keep it short and to the point. 0.83. What is the ratio of the Exports(as % of merchandise exports) of Uruguay in 2005 to that in 2010?
Keep it short and to the point. 1.23. What is the ratio of the Exports(as % of merchandise exports) of Chile in 2005 to that in 2011?
Provide a succinct answer. 1.1. What is the ratio of the Exports(as % of merchandise exports) of Guatemala in 2005 to that in 2011?
Offer a very short reply. 1.44. What is the ratio of the Exports(as % of merchandise exports) in Togo in 2005 to that in 2011?
Provide a succinct answer. 0.84. What is the ratio of the Exports(as % of merchandise exports) of Uruguay in 2005 to that in 2011?
Your answer should be compact. 1.14. What is the ratio of the Exports(as % of merchandise exports) in Chile in 2007 to that in 2008?
Give a very brief answer. 0.78. What is the ratio of the Exports(as % of merchandise exports) in Guatemala in 2007 to that in 2008?
Your response must be concise. 1.06. What is the ratio of the Exports(as % of merchandise exports) of Togo in 2007 to that in 2008?
Offer a terse response. 1.18. What is the ratio of the Exports(as % of merchandise exports) in Uruguay in 2007 to that in 2008?
Offer a terse response. 1.09. What is the ratio of the Exports(as % of merchandise exports) of Chile in 2007 to that in 2009?
Offer a very short reply. 0.92. What is the ratio of the Exports(as % of merchandise exports) in Guatemala in 2007 to that in 2009?
Keep it short and to the point. 1.15. What is the ratio of the Exports(as % of merchandise exports) of Togo in 2007 to that in 2009?
Offer a terse response. 1.15. What is the ratio of the Exports(as % of merchandise exports) in Uruguay in 2007 to that in 2009?
Keep it short and to the point. 1.24. What is the ratio of the Exports(as % of merchandise exports) in Chile in 2007 to that in 2010?
Offer a very short reply. 0.98. What is the ratio of the Exports(as % of merchandise exports) in Guatemala in 2007 to that in 2010?
Give a very brief answer. 1.16. What is the ratio of the Exports(as % of merchandise exports) of Togo in 2007 to that in 2010?
Make the answer very short. 0.89. What is the ratio of the Exports(as % of merchandise exports) in Uruguay in 2007 to that in 2010?
Offer a very short reply. 1.22. What is the ratio of the Exports(as % of merchandise exports) of Chile in 2007 to that in 2011?
Your response must be concise. 0.9. What is the ratio of the Exports(as % of merchandise exports) of Guatemala in 2007 to that in 2011?
Give a very brief answer. 1.26. What is the ratio of the Exports(as % of merchandise exports) of Togo in 2007 to that in 2011?
Ensure brevity in your answer.  0.89. What is the ratio of the Exports(as % of merchandise exports) in Uruguay in 2007 to that in 2011?
Your response must be concise. 1.13. What is the ratio of the Exports(as % of merchandise exports) of Chile in 2008 to that in 2009?
Offer a terse response. 1.19. What is the ratio of the Exports(as % of merchandise exports) in Guatemala in 2008 to that in 2009?
Provide a succinct answer. 1.09. What is the ratio of the Exports(as % of merchandise exports) of Togo in 2008 to that in 2009?
Your response must be concise. 0.98. What is the ratio of the Exports(as % of merchandise exports) in Uruguay in 2008 to that in 2009?
Give a very brief answer. 1.13. What is the ratio of the Exports(as % of merchandise exports) of Chile in 2008 to that in 2010?
Give a very brief answer. 1.26. What is the ratio of the Exports(as % of merchandise exports) of Guatemala in 2008 to that in 2010?
Offer a very short reply. 1.1. What is the ratio of the Exports(as % of merchandise exports) of Togo in 2008 to that in 2010?
Keep it short and to the point. 0.75. What is the ratio of the Exports(as % of merchandise exports) of Uruguay in 2008 to that in 2010?
Your answer should be compact. 1.12. What is the ratio of the Exports(as % of merchandise exports) in Chile in 2008 to that in 2011?
Your response must be concise. 1.16. What is the ratio of the Exports(as % of merchandise exports) of Guatemala in 2008 to that in 2011?
Your answer should be very brief. 1.19. What is the ratio of the Exports(as % of merchandise exports) in Togo in 2008 to that in 2011?
Provide a succinct answer. 0.76. What is the ratio of the Exports(as % of merchandise exports) in Uruguay in 2008 to that in 2011?
Offer a very short reply. 1.03. What is the ratio of the Exports(as % of merchandise exports) in Chile in 2009 to that in 2010?
Provide a short and direct response. 1.06. What is the ratio of the Exports(as % of merchandise exports) of Guatemala in 2009 to that in 2010?
Your answer should be compact. 1.01. What is the ratio of the Exports(as % of merchandise exports) in Togo in 2009 to that in 2010?
Offer a terse response. 0.77. What is the ratio of the Exports(as % of merchandise exports) of Uruguay in 2009 to that in 2010?
Your answer should be very brief. 0.98. What is the ratio of the Exports(as % of merchandise exports) of Chile in 2009 to that in 2011?
Offer a very short reply. 0.98. What is the ratio of the Exports(as % of merchandise exports) in Guatemala in 2009 to that in 2011?
Offer a very short reply. 1.1. What is the ratio of the Exports(as % of merchandise exports) in Togo in 2009 to that in 2011?
Keep it short and to the point. 0.77. What is the ratio of the Exports(as % of merchandise exports) in Uruguay in 2009 to that in 2011?
Make the answer very short. 0.91. What is the ratio of the Exports(as % of merchandise exports) in Chile in 2010 to that in 2011?
Give a very brief answer. 0.92. What is the ratio of the Exports(as % of merchandise exports) of Guatemala in 2010 to that in 2011?
Offer a terse response. 1.08. What is the ratio of the Exports(as % of merchandise exports) of Togo in 2010 to that in 2011?
Ensure brevity in your answer.  1.01. What is the ratio of the Exports(as % of merchandise exports) in Uruguay in 2010 to that in 2011?
Your answer should be compact. 0.93. What is the difference between the highest and the second highest Exports(as % of merchandise exports) in Chile?
Offer a very short reply. 0.87. What is the difference between the highest and the second highest Exports(as % of merchandise exports) of Guatemala?
Offer a very short reply. 7.04. What is the difference between the highest and the second highest Exports(as % of merchandise exports) of Togo?
Give a very brief answer. 0.56. What is the difference between the highest and the second highest Exports(as % of merchandise exports) of Uruguay?
Offer a very short reply. 0.28. What is the difference between the highest and the lowest Exports(as % of merchandise exports) of Chile?
Provide a succinct answer. 3.57. What is the difference between the highest and the lowest Exports(as % of merchandise exports) in Guatemala?
Ensure brevity in your answer.  17.38. What is the difference between the highest and the lowest Exports(as % of merchandise exports) of Togo?
Offer a very short reply. 17.55. What is the difference between the highest and the lowest Exports(as % of merchandise exports) of Uruguay?
Offer a very short reply. 6.33. 